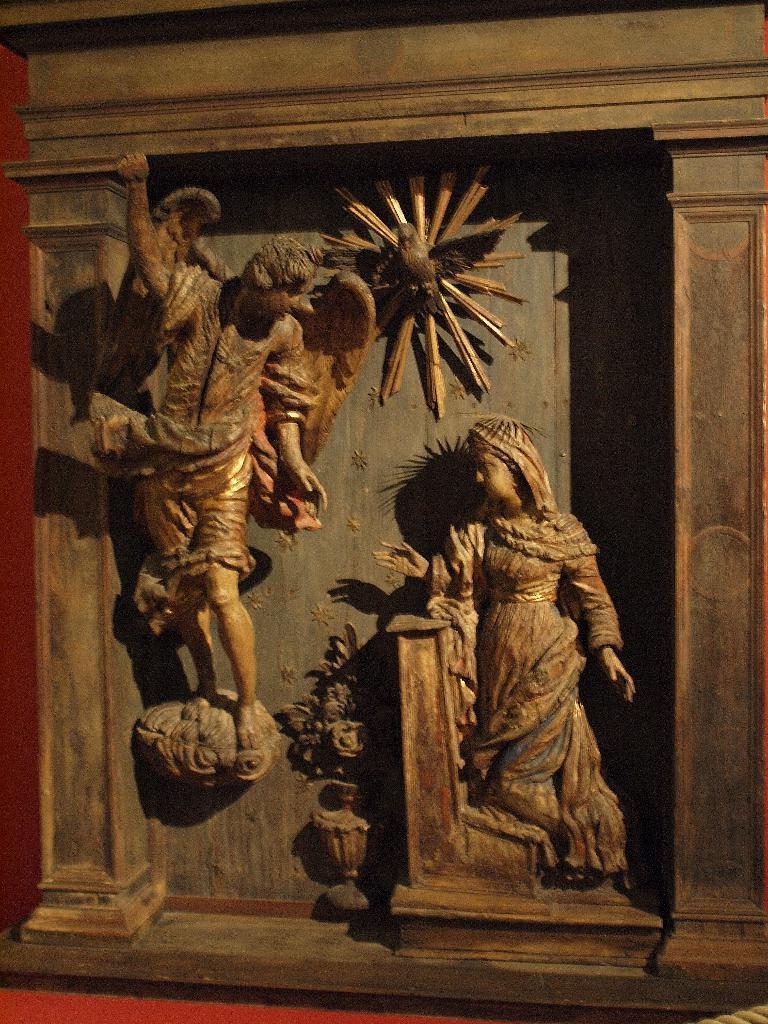Please provide a concise description of this image. In this image I see the wall on which there are sculptures which are of brown in color and I see the red color wall over here. 